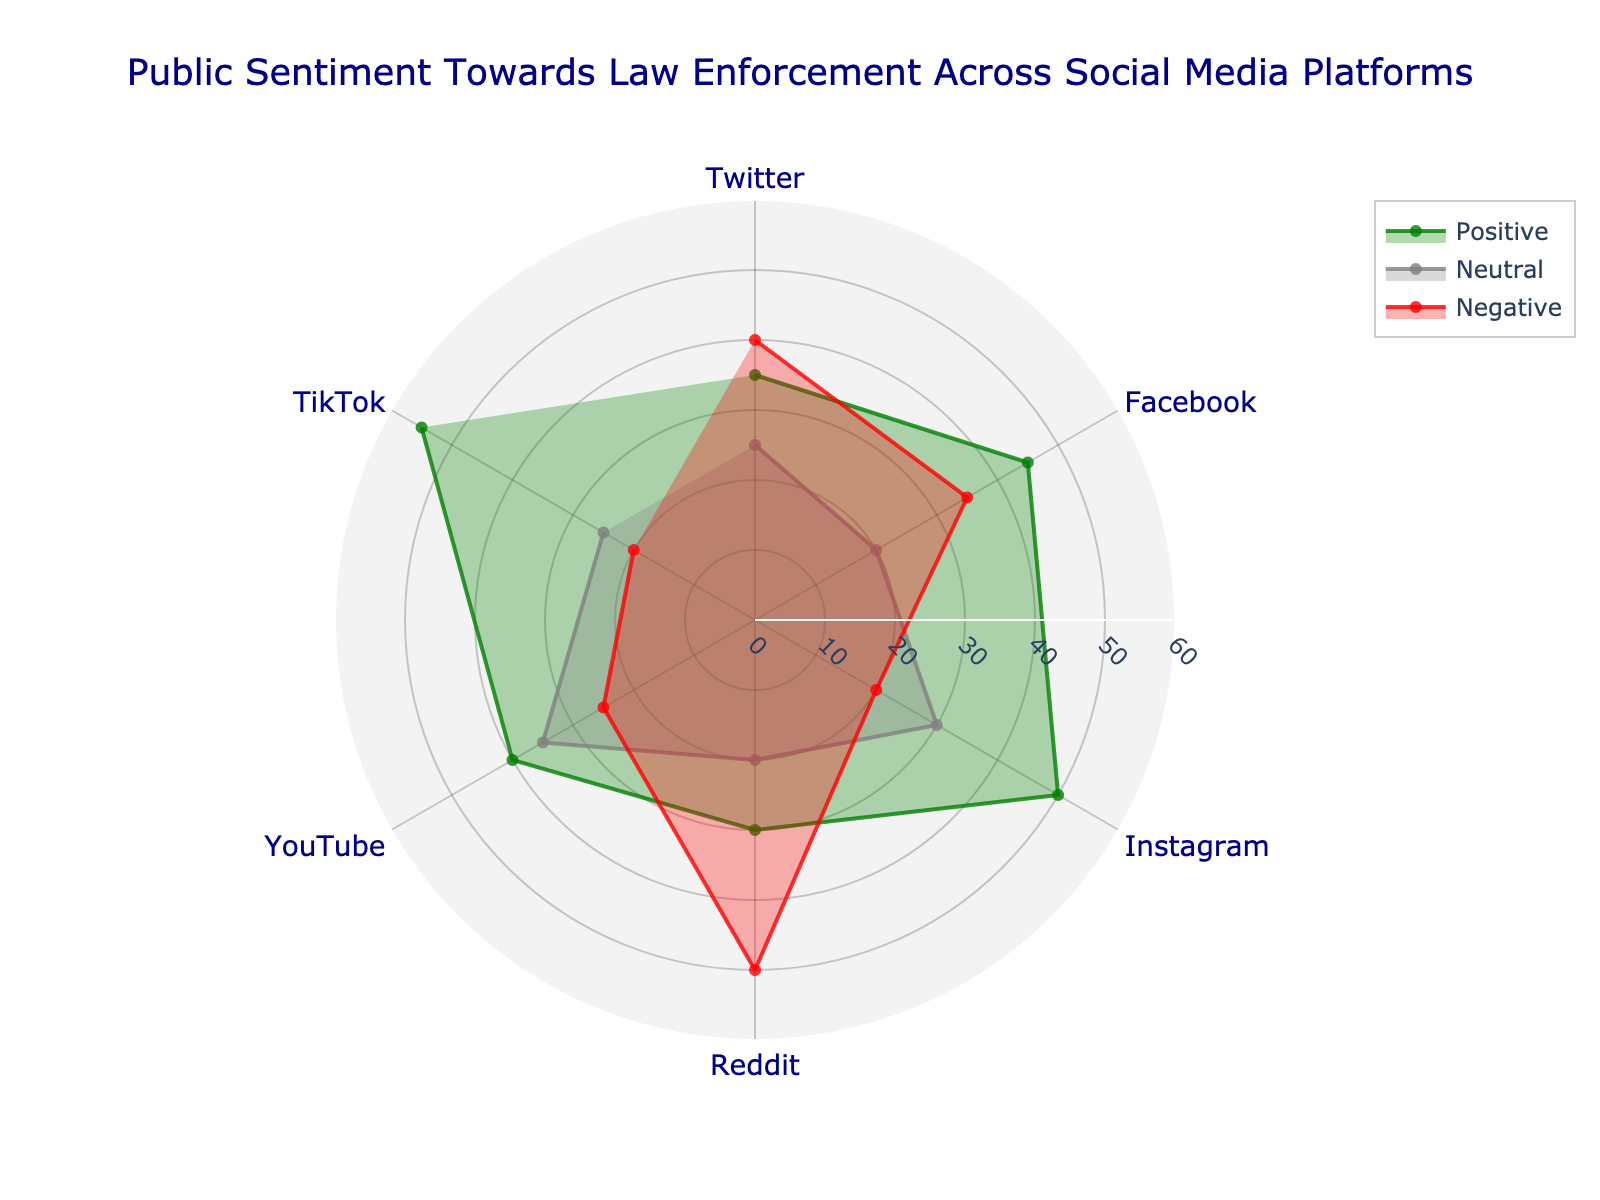What are the platforms covered in the chart? The platforms are listed as labels around the polar chart. You can see Twitter, Facebook, Instagram, Reddit, YouTube, and TikTok.
Answer: Twitter, Facebook, Instagram, Reddit, YouTube, TikTok Which platform has the highest positive sentiment? To find the highest positive sentiment, look at the green-filled area extending farthest from the center. TikTok has the highest value.
Answer: TikTok What is the general trend for negative sentiment across the platforms? By examining the red-filled areas, you can observe that Reddit has the highest negative sentiment, followed by Twitter. Instagram and TikTok have the lowest negative sentiment.
Answer: Ranges from low on Instagram and TikTok to high on Reddit and Twitter How does Twitter's positive sentiment compare to Facebook's? Twitter's positive sentiment is represented by the green area extending to 35, while Facebook's extends to 45. Facebook has higher positive sentiment.
Answer: Facebook has higher positive sentiment Which platform shows a balanced sentiment distribution? To find a balanced sentiment distribution, look for platforms where positive, neutral, and negative sentiments are roughly equal in size. YouTube's data shows relatively balanced sentiment across positive, neutral, and negative categories.
Answer: YouTube What is the average neutral sentiment across all platforms? Add all neutral sentiment values: 25 (Twitter) + 20 (Facebook) + 30 (Instagram) + 20 (Reddit) + 35 (YouTube) + 25 (TikTok) = 155. Then, divide by the number of platforms (6). The average is 155 / 6 ≈ 25.83.
Answer: ≈ 25.83 Which platform has the second-highest negative sentiment? By checking the red-filled areas, you can see that Reddit has the highest negative sentiment at 50. Twitter follows with the second-highest at 40.
Answer: Twitter What is the sum of positive sentiments for Instagram and TikTok? Positive sentiment for Instagram is 50, and for TikTok, it's 55. Adding these together: 50 + 55 = 105.
Answer: 105 How does the neutral sentiment for YouTube compare to that of Instagram? YouTube's neutral sentiment is 35, while Instagram's is 30. YouTube has a higher neutral sentiment than Instagram.
Answer: YouTube has higher neutral sentiment Which sentiment type shows the most significant variation among the platforms? By comparing the filled areas for each sentiment type, the red area (negative sentiment) shows the most significant variation, ranging from as low as 20 on Instagram and TikTok to as high as 50 on Reddit.
Answer: Negative sentiment 